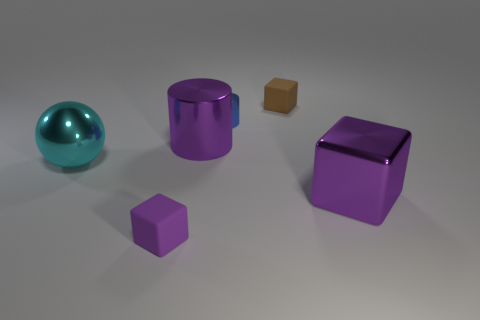Add 1 green matte spheres. How many objects exist? 7 Subtract all spheres. How many objects are left? 5 Add 1 big gray metallic blocks. How many big gray metallic blocks exist? 1 Subtract 0 yellow cylinders. How many objects are left? 6 Subtract all big metal spheres. Subtract all tiny shiny cylinders. How many objects are left? 4 Add 4 cyan metallic objects. How many cyan metallic objects are left? 5 